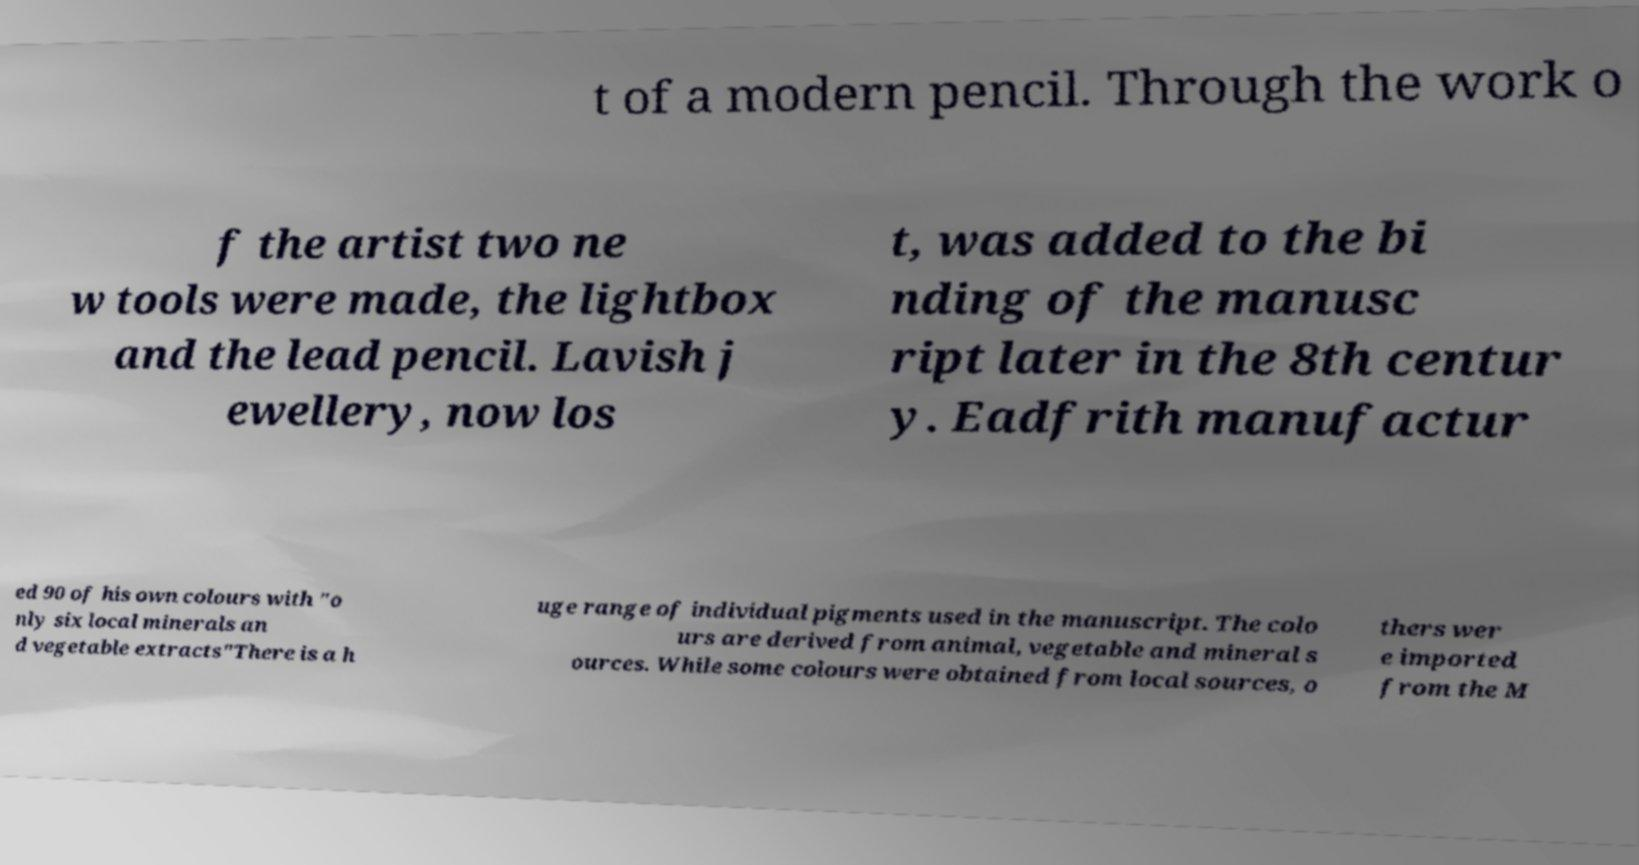What messages or text are displayed in this image? I need them in a readable, typed format. t of a modern pencil. Through the work o f the artist two ne w tools were made, the lightbox and the lead pencil. Lavish j ewellery, now los t, was added to the bi nding of the manusc ript later in the 8th centur y. Eadfrith manufactur ed 90 of his own colours with "o nly six local minerals an d vegetable extracts"There is a h uge range of individual pigments used in the manuscript. The colo urs are derived from animal, vegetable and mineral s ources. While some colours were obtained from local sources, o thers wer e imported from the M 